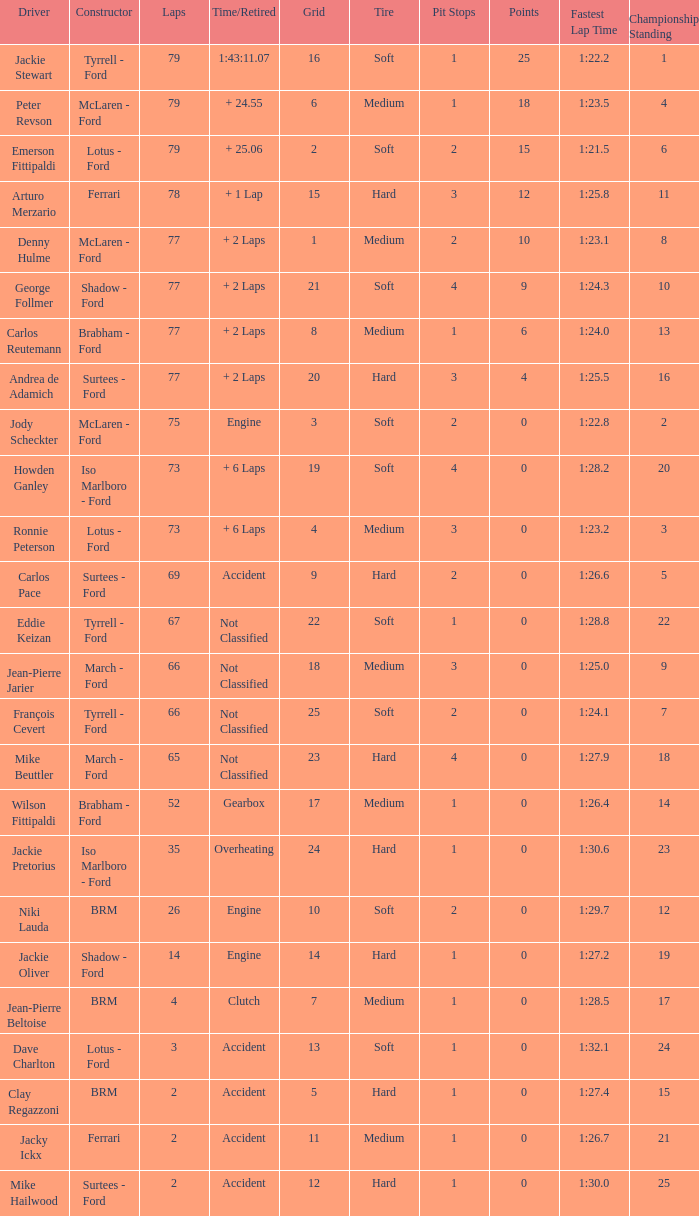What is the total grid with laps less than 2? None. 